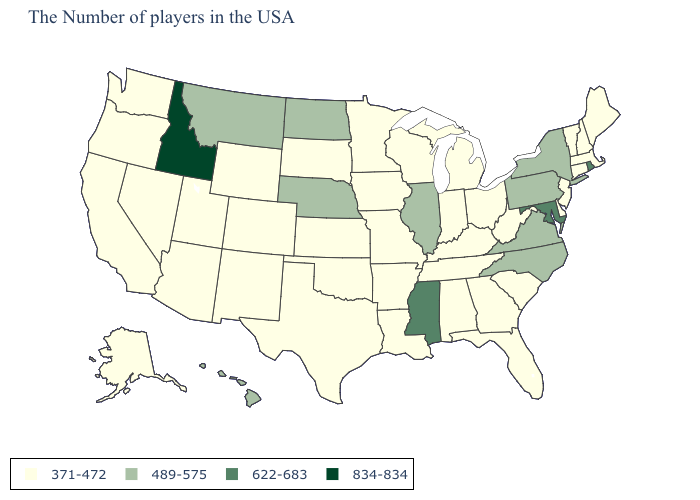What is the value of Missouri?
Concise answer only. 371-472. Does Arizona have the lowest value in the West?
Give a very brief answer. Yes. What is the value of Alaska?
Answer briefly. 371-472. Is the legend a continuous bar?
Be succinct. No. Name the states that have a value in the range 371-472?
Short answer required. Maine, Massachusetts, New Hampshire, Vermont, Connecticut, New Jersey, Delaware, South Carolina, West Virginia, Ohio, Florida, Georgia, Michigan, Kentucky, Indiana, Alabama, Tennessee, Wisconsin, Louisiana, Missouri, Arkansas, Minnesota, Iowa, Kansas, Oklahoma, Texas, South Dakota, Wyoming, Colorado, New Mexico, Utah, Arizona, Nevada, California, Washington, Oregon, Alaska. Name the states that have a value in the range 489-575?
Give a very brief answer. New York, Pennsylvania, Virginia, North Carolina, Illinois, Nebraska, North Dakota, Montana, Hawaii. Name the states that have a value in the range 834-834?
Quick response, please. Idaho. What is the highest value in states that border Colorado?
Give a very brief answer. 489-575. Name the states that have a value in the range 834-834?
Quick response, please. Idaho. Which states hav the highest value in the MidWest?
Be succinct. Illinois, Nebraska, North Dakota. Name the states that have a value in the range 834-834?
Write a very short answer. Idaho. Which states hav the highest value in the South?
Quick response, please. Maryland, Mississippi. What is the lowest value in the USA?
Be succinct. 371-472. What is the value of Florida?
Answer briefly. 371-472. Which states have the lowest value in the West?
Give a very brief answer. Wyoming, Colorado, New Mexico, Utah, Arizona, Nevada, California, Washington, Oregon, Alaska. 